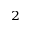<formula> <loc_0><loc_0><loc_500><loc_500>^ { 2 }</formula> 